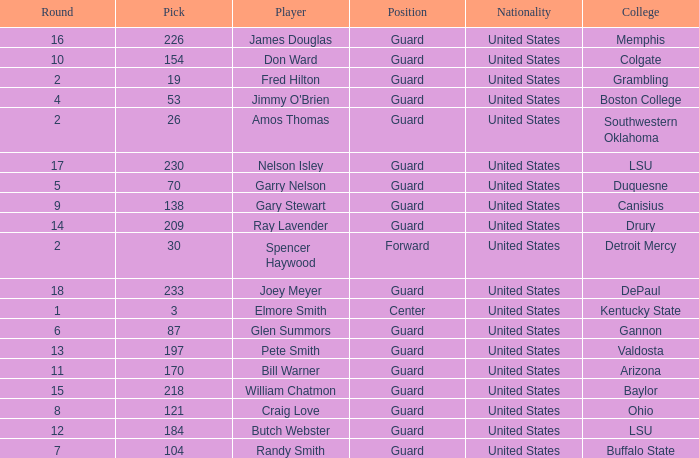WHAT POSITION HAS A ROUND LARGER THAN 2, FOR VALDOSTA COLLEGE? Guard. 